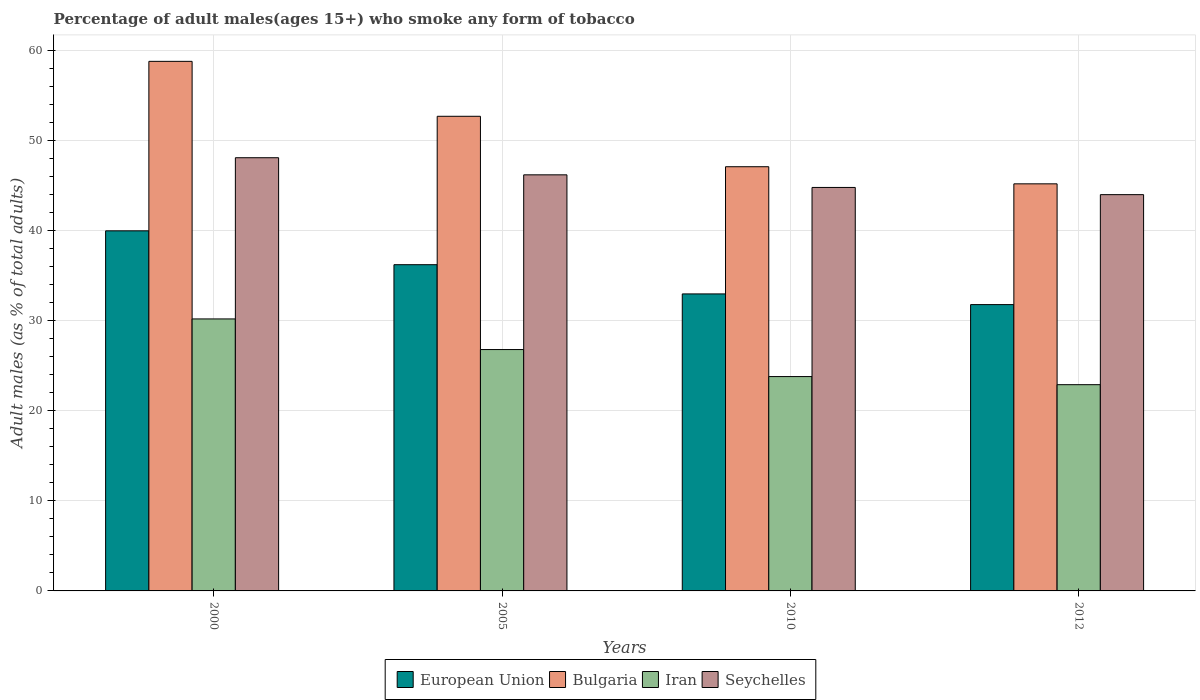How many different coloured bars are there?
Provide a succinct answer. 4. How many groups of bars are there?
Provide a succinct answer. 4. How many bars are there on the 2nd tick from the left?
Offer a terse response. 4. In how many cases, is the number of bars for a given year not equal to the number of legend labels?
Make the answer very short. 0. What is the percentage of adult males who smoke in Seychelles in 2005?
Your answer should be very brief. 46.2. Across all years, what is the maximum percentage of adult males who smoke in Bulgaria?
Keep it short and to the point. 58.8. Across all years, what is the minimum percentage of adult males who smoke in European Union?
Give a very brief answer. 31.79. In which year was the percentage of adult males who smoke in Bulgaria maximum?
Your response must be concise. 2000. In which year was the percentage of adult males who smoke in Seychelles minimum?
Your response must be concise. 2012. What is the total percentage of adult males who smoke in Seychelles in the graph?
Provide a short and direct response. 183.1. What is the difference between the percentage of adult males who smoke in Seychelles in 2000 and that in 2005?
Your answer should be very brief. 1.9. What is the difference between the percentage of adult males who smoke in European Union in 2005 and the percentage of adult males who smoke in Iran in 2012?
Your answer should be very brief. 13.32. What is the average percentage of adult males who smoke in Iran per year?
Make the answer very short. 25.92. In the year 2010, what is the difference between the percentage of adult males who smoke in Bulgaria and percentage of adult males who smoke in European Union?
Your response must be concise. 14.12. What is the ratio of the percentage of adult males who smoke in Seychelles in 2000 to that in 2010?
Give a very brief answer. 1.07. Is the percentage of adult males who smoke in Iran in 2000 less than that in 2010?
Make the answer very short. No. What is the difference between the highest and the second highest percentage of adult males who smoke in Bulgaria?
Provide a short and direct response. 6.1. What is the difference between the highest and the lowest percentage of adult males who smoke in Seychelles?
Make the answer very short. 4.1. In how many years, is the percentage of adult males who smoke in Bulgaria greater than the average percentage of adult males who smoke in Bulgaria taken over all years?
Your answer should be compact. 2. Is it the case that in every year, the sum of the percentage of adult males who smoke in Iran and percentage of adult males who smoke in Seychelles is greater than the sum of percentage of adult males who smoke in European Union and percentage of adult males who smoke in Bulgaria?
Your answer should be very brief. No. What does the 4th bar from the right in 2012 represents?
Your answer should be compact. European Union. How many bars are there?
Your answer should be very brief. 16. Are all the bars in the graph horizontal?
Keep it short and to the point. No. What is the difference between two consecutive major ticks on the Y-axis?
Provide a short and direct response. 10. Are the values on the major ticks of Y-axis written in scientific E-notation?
Offer a terse response. No. Does the graph contain grids?
Offer a very short reply. Yes. What is the title of the graph?
Your response must be concise. Percentage of adult males(ages 15+) who smoke any form of tobacco. Does "Sweden" appear as one of the legend labels in the graph?
Provide a short and direct response. No. What is the label or title of the Y-axis?
Ensure brevity in your answer.  Adult males (as % of total adults). What is the Adult males (as % of total adults) in European Union in 2000?
Your response must be concise. 39.98. What is the Adult males (as % of total adults) of Bulgaria in 2000?
Provide a succinct answer. 58.8. What is the Adult males (as % of total adults) of Iran in 2000?
Give a very brief answer. 30.2. What is the Adult males (as % of total adults) in Seychelles in 2000?
Offer a very short reply. 48.1. What is the Adult males (as % of total adults) in European Union in 2005?
Make the answer very short. 36.22. What is the Adult males (as % of total adults) of Bulgaria in 2005?
Make the answer very short. 52.7. What is the Adult males (as % of total adults) of Iran in 2005?
Give a very brief answer. 26.8. What is the Adult males (as % of total adults) in Seychelles in 2005?
Your answer should be very brief. 46.2. What is the Adult males (as % of total adults) of European Union in 2010?
Provide a succinct answer. 32.98. What is the Adult males (as % of total adults) in Bulgaria in 2010?
Offer a very short reply. 47.1. What is the Adult males (as % of total adults) of Iran in 2010?
Give a very brief answer. 23.8. What is the Adult males (as % of total adults) in Seychelles in 2010?
Offer a very short reply. 44.8. What is the Adult males (as % of total adults) in European Union in 2012?
Offer a very short reply. 31.79. What is the Adult males (as % of total adults) in Bulgaria in 2012?
Your answer should be compact. 45.2. What is the Adult males (as % of total adults) of Iran in 2012?
Offer a very short reply. 22.9. What is the Adult males (as % of total adults) of Seychelles in 2012?
Give a very brief answer. 44. Across all years, what is the maximum Adult males (as % of total adults) in European Union?
Offer a very short reply. 39.98. Across all years, what is the maximum Adult males (as % of total adults) in Bulgaria?
Offer a terse response. 58.8. Across all years, what is the maximum Adult males (as % of total adults) in Iran?
Provide a short and direct response. 30.2. Across all years, what is the maximum Adult males (as % of total adults) in Seychelles?
Provide a succinct answer. 48.1. Across all years, what is the minimum Adult males (as % of total adults) of European Union?
Your answer should be very brief. 31.79. Across all years, what is the minimum Adult males (as % of total adults) of Bulgaria?
Provide a short and direct response. 45.2. Across all years, what is the minimum Adult males (as % of total adults) of Iran?
Offer a terse response. 22.9. What is the total Adult males (as % of total adults) in European Union in the graph?
Make the answer very short. 140.97. What is the total Adult males (as % of total adults) of Bulgaria in the graph?
Give a very brief answer. 203.8. What is the total Adult males (as % of total adults) in Iran in the graph?
Give a very brief answer. 103.7. What is the total Adult males (as % of total adults) of Seychelles in the graph?
Your answer should be very brief. 183.1. What is the difference between the Adult males (as % of total adults) of European Union in 2000 and that in 2005?
Your response must be concise. 3.76. What is the difference between the Adult males (as % of total adults) of Iran in 2000 and that in 2005?
Your response must be concise. 3.4. What is the difference between the Adult males (as % of total adults) of Seychelles in 2000 and that in 2005?
Give a very brief answer. 1.9. What is the difference between the Adult males (as % of total adults) in European Union in 2000 and that in 2010?
Give a very brief answer. 7. What is the difference between the Adult males (as % of total adults) of Iran in 2000 and that in 2010?
Ensure brevity in your answer.  6.4. What is the difference between the Adult males (as % of total adults) in Seychelles in 2000 and that in 2010?
Ensure brevity in your answer.  3.3. What is the difference between the Adult males (as % of total adults) in European Union in 2000 and that in 2012?
Provide a succinct answer. 8.19. What is the difference between the Adult males (as % of total adults) of Iran in 2000 and that in 2012?
Your answer should be compact. 7.3. What is the difference between the Adult males (as % of total adults) of European Union in 2005 and that in 2010?
Ensure brevity in your answer.  3.24. What is the difference between the Adult males (as % of total adults) of Bulgaria in 2005 and that in 2010?
Your response must be concise. 5.6. What is the difference between the Adult males (as % of total adults) of Seychelles in 2005 and that in 2010?
Make the answer very short. 1.4. What is the difference between the Adult males (as % of total adults) in European Union in 2005 and that in 2012?
Provide a short and direct response. 4.43. What is the difference between the Adult males (as % of total adults) in Bulgaria in 2005 and that in 2012?
Your answer should be compact. 7.5. What is the difference between the Adult males (as % of total adults) in Iran in 2005 and that in 2012?
Provide a succinct answer. 3.9. What is the difference between the Adult males (as % of total adults) of European Union in 2010 and that in 2012?
Provide a short and direct response. 1.19. What is the difference between the Adult males (as % of total adults) in Bulgaria in 2010 and that in 2012?
Provide a short and direct response. 1.9. What is the difference between the Adult males (as % of total adults) of Seychelles in 2010 and that in 2012?
Offer a very short reply. 0.8. What is the difference between the Adult males (as % of total adults) in European Union in 2000 and the Adult males (as % of total adults) in Bulgaria in 2005?
Give a very brief answer. -12.72. What is the difference between the Adult males (as % of total adults) in European Union in 2000 and the Adult males (as % of total adults) in Iran in 2005?
Your answer should be very brief. 13.18. What is the difference between the Adult males (as % of total adults) in European Union in 2000 and the Adult males (as % of total adults) in Seychelles in 2005?
Your response must be concise. -6.22. What is the difference between the Adult males (as % of total adults) of Bulgaria in 2000 and the Adult males (as % of total adults) of Iran in 2005?
Your response must be concise. 32. What is the difference between the Adult males (as % of total adults) in Iran in 2000 and the Adult males (as % of total adults) in Seychelles in 2005?
Give a very brief answer. -16. What is the difference between the Adult males (as % of total adults) in European Union in 2000 and the Adult males (as % of total adults) in Bulgaria in 2010?
Your answer should be very brief. -7.12. What is the difference between the Adult males (as % of total adults) of European Union in 2000 and the Adult males (as % of total adults) of Iran in 2010?
Provide a succinct answer. 16.18. What is the difference between the Adult males (as % of total adults) of European Union in 2000 and the Adult males (as % of total adults) of Seychelles in 2010?
Provide a short and direct response. -4.82. What is the difference between the Adult males (as % of total adults) of Bulgaria in 2000 and the Adult males (as % of total adults) of Iran in 2010?
Offer a very short reply. 35. What is the difference between the Adult males (as % of total adults) of Iran in 2000 and the Adult males (as % of total adults) of Seychelles in 2010?
Provide a short and direct response. -14.6. What is the difference between the Adult males (as % of total adults) of European Union in 2000 and the Adult males (as % of total adults) of Bulgaria in 2012?
Keep it short and to the point. -5.22. What is the difference between the Adult males (as % of total adults) in European Union in 2000 and the Adult males (as % of total adults) in Iran in 2012?
Your answer should be compact. 17.08. What is the difference between the Adult males (as % of total adults) in European Union in 2000 and the Adult males (as % of total adults) in Seychelles in 2012?
Keep it short and to the point. -4.02. What is the difference between the Adult males (as % of total adults) in Bulgaria in 2000 and the Adult males (as % of total adults) in Iran in 2012?
Offer a terse response. 35.9. What is the difference between the Adult males (as % of total adults) of Iran in 2000 and the Adult males (as % of total adults) of Seychelles in 2012?
Ensure brevity in your answer.  -13.8. What is the difference between the Adult males (as % of total adults) in European Union in 2005 and the Adult males (as % of total adults) in Bulgaria in 2010?
Your response must be concise. -10.88. What is the difference between the Adult males (as % of total adults) of European Union in 2005 and the Adult males (as % of total adults) of Iran in 2010?
Provide a short and direct response. 12.42. What is the difference between the Adult males (as % of total adults) in European Union in 2005 and the Adult males (as % of total adults) in Seychelles in 2010?
Provide a short and direct response. -8.58. What is the difference between the Adult males (as % of total adults) in Bulgaria in 2005 and the Adult males (as % of total adults) in Iran in 2010?
Offer a very short reply. 28.9. What is the difference between the Adult males (as % of total adults) of European Union in 2005 and the Adult males (as % of total adults) of Bulgaria in 2012?
Ensure brevity in your answer.  -8.98. What is the difference between the Adult males (as % of total adults) in European Union in 2005 and the Adult males (as % of total adults) in Iran in 2012?
Provide a short and direct response. 13.32. What is the difference between the Adult males (as % of total adults) of European Union in 2005 and the Adult males (as % of total adults) of Seychelles in 2012?
Offer a terse response. -7.78. What is the difference between the Adult males (as % of total adults) of Bulgaria in 2005 and the Adult males (as % of total adults) of Iran in 2012?
Offer a terse response. 29.8. What is the difference between the Adult males (as % of total adults) in Iran in 2005 and the Adult males (as % of total adults) in Seychelles in 2012?
Offer a terse response. -17.2. What is the difference between the Adult males (as % of total adults) of European Union in 2010 and the Adult males (as % of total adults) of Bulgaria in 2012?
Ensure brevity in your answer.  -12.22. What is the difference between the Adult males (as % of total adults) in European Union in 2010 and the Adult males (as % of total adults) in Iran in 2012?
Offer a very short reply. 10.08. What is the difference between the Adult males (as % of total adults) in European Union in 2010 and the Adult males (as % of total adults) in Seychelles in 2012?
Make the answer very short. -11.02. What is the difference between the Adult males (as % of total adults) in Bulgaria in 2010 and the Adult males (as % of total adults) in Iran in 2012?
Your answer should be compact. 24.2. What is the difference between the Adult males (as % of total adults) in Iran in 2010 and the Adult males (as % of total adults) in Seychelles in 2012?
Make the answer very short. -20.2. What is the average Adult males (as % of total adults) of European Union per year?
Give a very brief answer. 35.24. What is the average Adult males (as % of total adults) in Bulgaria per year?
Provide a succinct answer. 50.95. What is the average Adult males (as % of total adults) of Iran per year?
Offer a very short reply. 25.93. What is the average Adult males (as % of total adults) in Seychelles per year?
Offer a very short reply. 45.77. In the year 2000, what is the difference between the Adult males (as % of total adults) in European Union and Adult males (as % of total adults) in Bulgaria?
Make the answer very short. -18.82. In the year 2000, what is the difference between the Adult males (as % of total adults) of European Union and Adult males (as % of total adults) of Iran?
Keep it short and to the point. 9.78. In the year 2000, what is the difference between the Adult males (as % of total adults) of European Union and Adult males (as % of total adults) of Seychelles?
Make the answer very short. -8.12. In the year 2000, what is the difference between the Adult males (as % of total adults) of Bulgaria and Adult males (as % of total adults) of Iran?
Your answer should be very brief. 28.6. In the year 2000, what is the difference between the Adult males (as % of total adults) of Bulgaria and Adult males (as % of total adults) of Seychelles?
Provide a short and direct response. 10.7. In the year 2000, what is the difference between the Adult males (as % of total adults) in Iran and Adult males (as % of total adults) in Seychelles?
Provide a short and direct response. -17.9. In the year 2005, what is the difference between the Adult males (as % of total adults) of European Union and Adult males (as % of total adults) of Bulgaria?
Make the answer very short. -16.48. In the year 2005, what is the difference between the Adult males (as % of total adults) in European Union and Adult males (as % of total adults) in Iran?
Offer a very short reply. 9.42. In the year 2005, what is the difference between the Adult males (as % of total adults) in European Union and Adult males (as % of total adults) in Seychelles?
Your answer should be compact. -9.98. In the year 2005, what is the difference between the Adult males (as % of total adults) of Bulgaria and Adult males (as % of total adults) of Iran?
Make the answer very short. 25.9. In the year 2005, what is the difference between the Adult males (as % of total adults) in Iran and Adult males (as % of total adults) in Seychelles?
Give a very brief answer. -19.4. In the year 2010, what is the difference between the Adult males (as % of total adults) in European Union and Adult males (as % of total adults) in Bulgaria?
Provide a short and direct response. -14.12. In the year 2010, what is the difference between the Adult males (as % of total adults) in European Union and Adult males (as % of total adults) in Iran?
Provide a short and direct response. 9.18. In the year 2010, what is the difference between the Adult males (as % of total adults) of European Union and Adult males (as % of total adults) of Seychelles?
Make the answer very short. -11.82. In the year 2010, what is the difference between the Adult males (as % of total adults) of Bulgaria and Adult males (as % of total adults) of Iran?
Provide a succinct answer. 23.3. In the year 2010, what is the difference between the Adult males (as % of total adults) of Bulgaria and Adult males (as % of total adults) of Seychelles?
Offer a terse response. 2.3. In the year 2010, what is the difference between the Adult males (as % of total adults) of Iran and Adult males (as % of total adults) of Seychelles?
Make the answer very short. -21. In the year 2012, what is the difference between the Adult males (as % of total adults) of European Union and Adult males (as % of total adults) of Bulgaria?
Offer a terse response. -13.41. In the year 2012, what is the difference between the Adult males (as % of total adults) in European Union and Adult males (as % of total adults) in Iran?
Keep it short and to the point. 8.89. In the year 2012, what is the difference between the Adult males (as % of total adults) of European Union and Adult males (as % of total adults) of Seychelles?
Make the answer very short. -12.21. In the year 2012, what is the difference between the Adult males (as % of total adults) in Bulgaria and Adult males (as % of total adults) in Iran?
Provide a short and direct response. 22.3. In the year 2012, what is the difference between the Adult males (as % of total adults) of Iran and Adult males (as % of total adults) of Seychelles?
Your answer should be very brief. -21.1. What is the ratio of the Adult males (as % of total adults) of European Union in 2000 to that in 2005?
Your answer should be compact. 1.1. What is the ratio of the Adult males (as % of total adults) in Bulgaria in 2000 to that in 2005?
Give a very brief answer. 1.12. What is the ratio of the Adult males (as % of total adults) of Iran in 2000 to that in 2005?
Your answer should be very brief. 1.13. What is the ratio of the Adult males (as % of total adults) in Seychelles in 2000 to that in 2005?
Offer a terse response. 1.04. What is the ratio of the Adult males (as % of total adults) of European Union in 2000 to that in 2010?
Give a very brief answer. 1.21. What is the ratio of the Adult males (as % of total adults) in Bulgaria in 2000 to that in 2010?
Your answer should be very brief. 1.25. What is the ratio of the Adult males (as % of total adults) in Iran in 2000 to that in 2010?
Offer a very short reply. 1.27. What is the ratio of the Adult males (as % of total adults) of Seychelles in 2000 to that in 2010?
Offer a terse response. 1.07. What is the ratio of the Adult males (as % of total adults) of European Union in 2000 to that in 2012?
Make the answer very short. 1.26. What is the ratio of the Adult males (as % of total adults) in Bulgaria in 2000 to that in 2012?
Give a very brief answer. 1.3. What is the ratio of the Adult males (as % of total adults) of Iran in 2000 to that in 2012?
Provide a short and direct response. 1.32. What is the ratio of the Adult males (as % of total adults) of Seychelles in 2000 to that in 2012?
Offer a very short reply. 1.09. What is the ratio of the Adult males (as % of total adults) of European Union in 2005 to that in 2010?
Your answer should be very brief. 1.1. What is the ratio of the Adult males (as % of total adults) of Bulgaria in 2005 to that in 2010?
Your response must be concise. 1.12. What is the ratio of the Adult males (as % of total adults) of Iran in 2005 to that in 2010?
Keep it short and to the point. 1.13. What is the ratio of the Adult males (as % of total adults) of Seychelles in 2005 to that in 2010?
Make the answer very short. 1.03. What is the ratio of the Adult males (as % of total adults) in European Union in 2005 to that in 2012?
Offer a very short reply. 1.14. What is the ratio of the Adult males (as % of total adults) in Bulgaria in 2005 to that in 2012?
Your answer should be compact. 1.17. What is the ratio of the Adult males (as % of total adults) in Iran in 2005 to that in 2012?
Give a very brief answer. 1.17. What is the ratio of the Adult males (as % of total adults) in Seychelles in 2005 to that in 2012?
Make the answer very short. 1.05. What is the ratio of the Adult males (as % of total adults) of European Union in 2010 to that in 2012?
Your answer should be very brief. 1.04. What is the ratio of the Adult males (as % of total adults) in Bulgaria in 2010 to that in 2012?
Keep it short and to the point. 1.04. What is the ratio of the Adult males (as % of total adults) in Iran in 2010 to that in 2012?
Ensure brevity in your answer.  1.04. What is the ratio of the Adult males (as % of total adults) in Seychelles in 2010 to that in 2012?
Make the answer very short. 1.02. What is the difference between the highest and the second highest Adult males (as % of total adults) of European Union?
Offer a very short reply. 3.76. What is the difference between the highest and the second highest Adult males (as % of total adults) of Seychelles?
Your answer should be compact. 1.9. What is the difference between the highest and the lowest Adult males (as % of total adults) of European Union?
Offer a very short reply. 8.19. What is the difference between the highest and the lowest Adult males (as % of total adults) of Bulgaria?
Ensure brevity in your answer.  13.6. What is the difference between the highest and the lowest Adult males (as % of total adults) in Seychelles?
Make the answer very short. 4.1. 